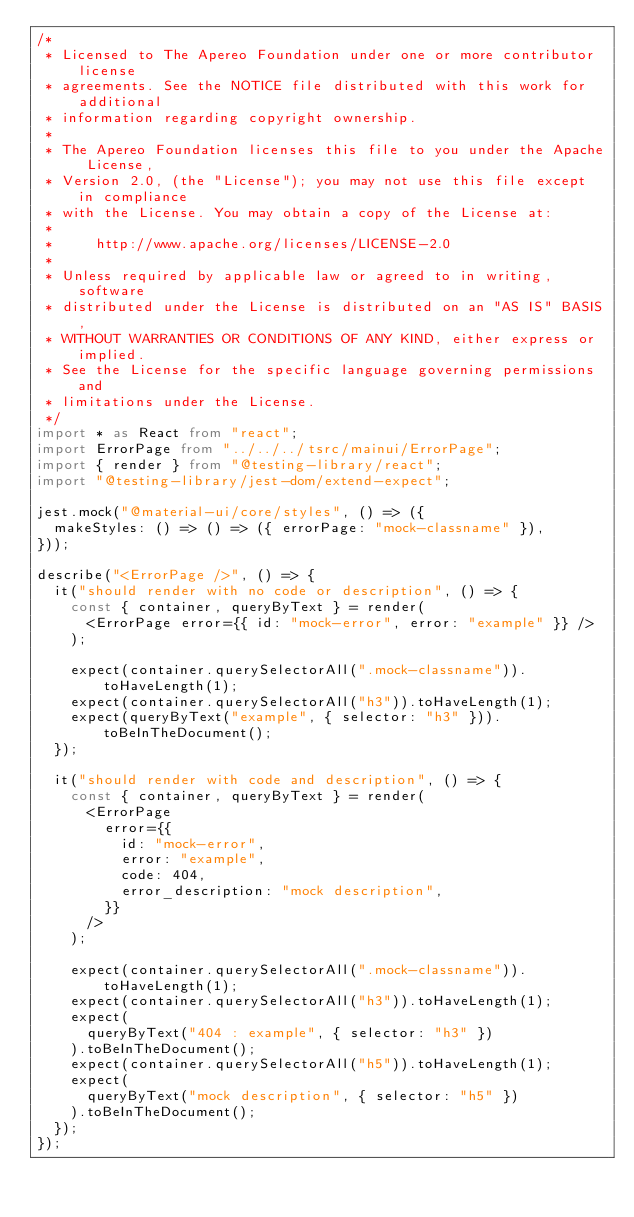Convert code to text. <code><loc_0><loc_0><loc_500><loc_500><_TypeScript_>/*
 * Licensed to The Apereo Foundation under one or more contributor license
 * agreements. See the NOTICE file distributed with this work for additional
 * information regarding copyright ownership.
 *
 * The Apereo Foundation licenses this file to you under the Apache License,
 * Version 2.0, (the "License"); you may not use this file except in compliance
 * with the License. You may obtain a copy of the License at:
 *
 *     http://www.apache.org/licenses/LICENSE-2.0
 *
 * Unless required by applicable law or agreed to in writing, software
 * distributed under the License is distributed on an "AS IS" BASIS,
 * WITHOUT WARRANTIES OR CONDITIONS OF ANY KIND, either express or implied.
 * See the License for the specific language governing permissions and
 * limitations under the License.
 */
import * as React from "react";
import ErrorPage from "../../../tsrc/mainui/ErrorPage";
import { render } from "@testing-library/react";
import "@testing-library/jest-dom/extend-expect";

jest.mock("@material-ui/core/styles", () => ({
  makeStyles: () => () => ({ errorPage: "mock-classname" }),
}));

describe("<ErrorPage />", () => {
  it("should render with no code or description", () => {
    const { container, queryByText } = render(
      <ErrorPage error={{ id: "mock-error", error: "example" }} />
    );

    expect(container.querySelectorAll(".mock-classname")).toHaveLength(1);
    expect(container.querySelectorAll("h3")).toHaveLength(1);
    expect(queryByText("example", { selector: "h3" })).toBeInTheDocument();
  });

  it("should render with code and description", () => {
    const { container, queryByText } = render(
      <ErrorPage
        error={{
          id: "mock-error",
          error: "example",
          code: 404,
          error_description: "mock description",
        }}
      />
    );

    expect(container.querySelectorAll(".mock-classname")).toHaveLength(1);
    expect(container.querySelectorAll("h3")).toHaveLength(1);
    expect(
      queryByText("404 : example", { selector: "h3" })
    ).toBeInTheDocument();
    expect(container.querySelectorAll("h5")).toHaveLength(1);
    expect(
      queryByText("mock description", { selector: "h5" })
    ).toBeInTheDocument();
  });
});
</code> 